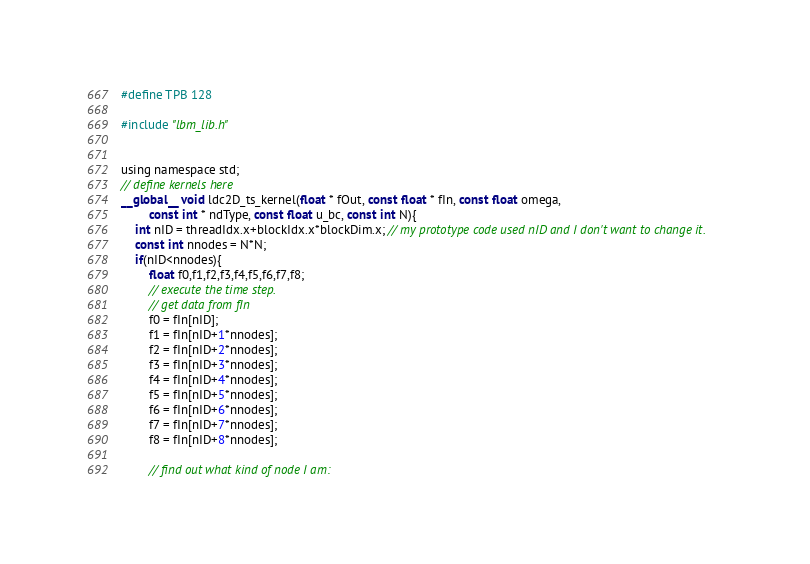Convert code to text. <code><loc_0><loc_0><loc_500><loc_500><_Cuda_>#define TPB 128

#include "lbm_lib.h"


using namespace std;
// define kernels here
__global__ void ldc2D_ts_kernel(float * fOut, const float * fIn, const float omega,
		const int * ndType, const float u_bc, const int N){
	int nID = threadIdx.x+blockIdx.x*blockDim.x; // my prototype code used nID and I don't want to change it.
	const int nnodes = N*N;
	if(nID<nnodes){
		float f0,f1,f2,f3,f4,f5,f6,f7,f8;
		// execute the time step.
		// get data from fIn
		f0 = fIn[nID];
		f1 = fIn[nID+1*nnodes];
		f2 = fIn[nID+2*nnodes];
		f3 = fIn[nID+3*nnodes];
		f4 = fIn[nID+4*nnodes];
		f5 = fIn[nID+5*nnodes];
		f6 = fIn[nID+6*nnodes];
		f7 = fIn[nID+7*nnodes];
		f8 = fIn[nID+8*nnodes];

		// find out what kind of node I am:</code> 